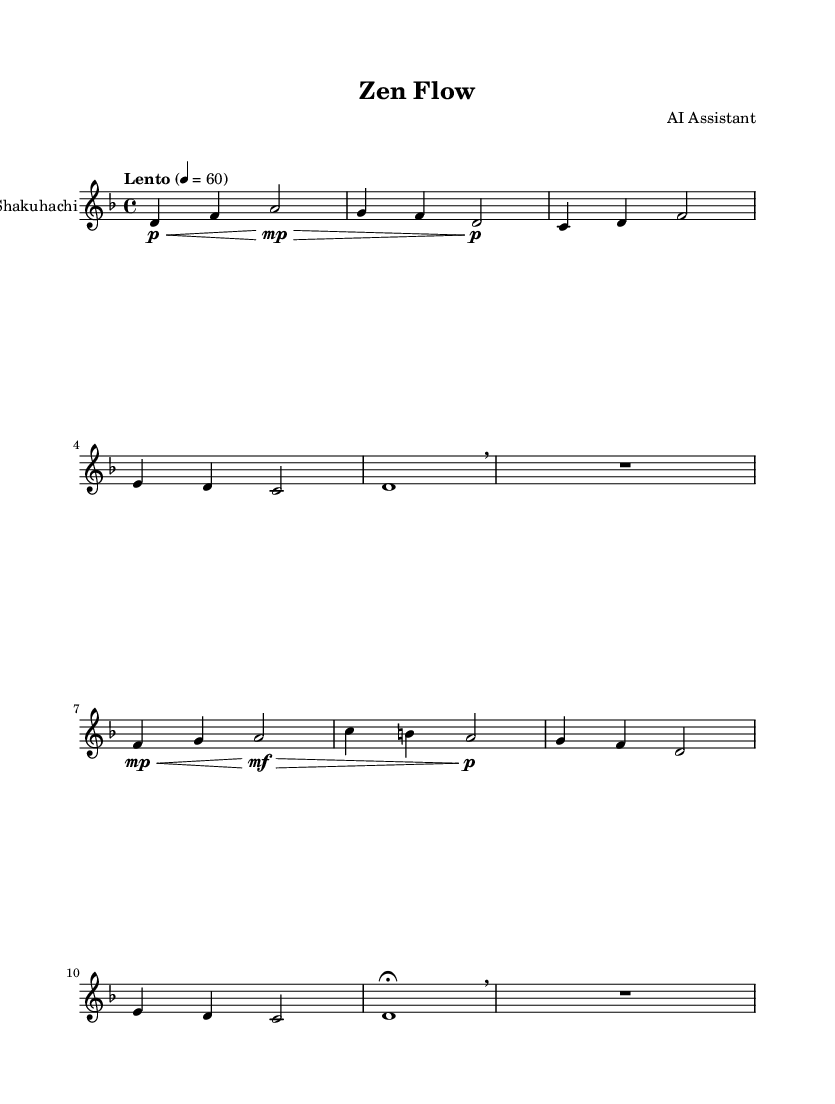What is the key signature of this music? The key signature is indicated at the beginning of the staff. In this case, it shows one flat, which corresponds to D minor.
Answer: D minor What is the time signature of this music? The time signature is located right after the key signature at the beginning of the staff. It shows the fraction 4 over 4, indicating a common time.
Answer: 4/4 What is the tempo marking of this piece? The tempo is indicated above the staff in musical terms. Here, it states "Lento," which means slow, with a metronome marking of 60 beats per minute.
Answer: Lento How many measures are in this piece? To determine the number of measures, we can count the distinct groups of beats separated by vertical lines in the score. There are 8 measures.
Answer: 8 What is the dynamic marking for the first measure? The dynamic marking in the first measure is indicated as a "p," standing for piano, which means soft.
Answer: piano What breath mark appears in this composition, and how many times is it used? The breath mark is indicated with a specific symbol, usually resembling a small comma. In this composition, it appears twice throughout the piece.
Answer: 2 How does this music fit into the concept of mindfulness? The piece's slow tempo, gentle dynamics, and use of breath marks are designed to create a calming sound environment conducive to mindfulness and stress reduction.
Answer: Calm 